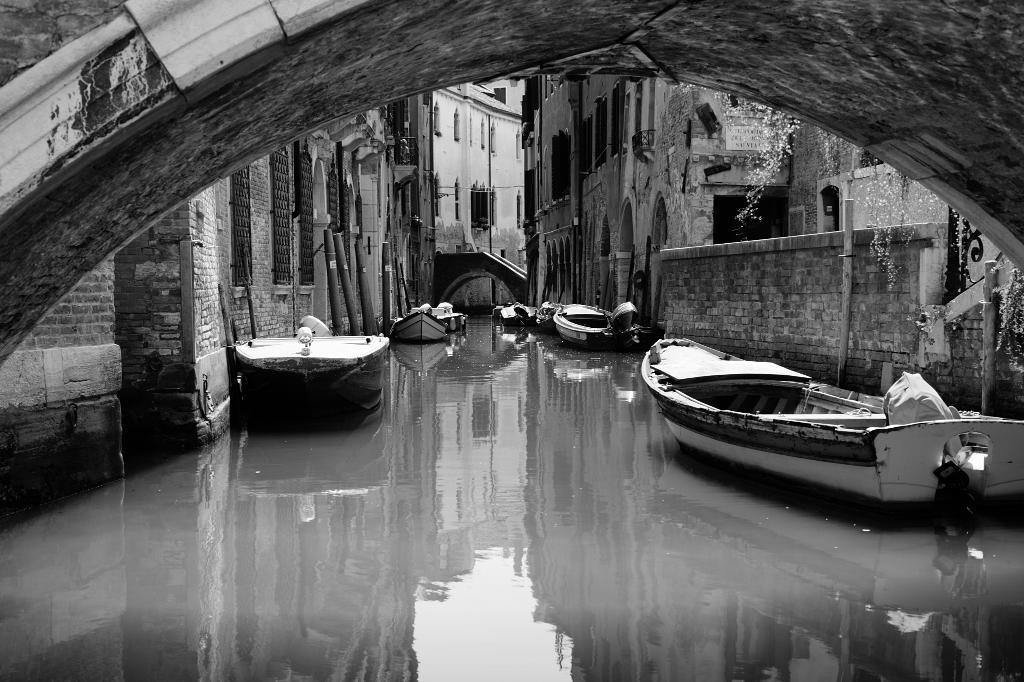What is in the water in the image? There are boats in the water in the image. What can be seen in the background of the image? There are buildings and a bridge in the background. What type of thunder can be heard in the image? There is no thunder present in the image, as it is a visual representation and does not include sound. 